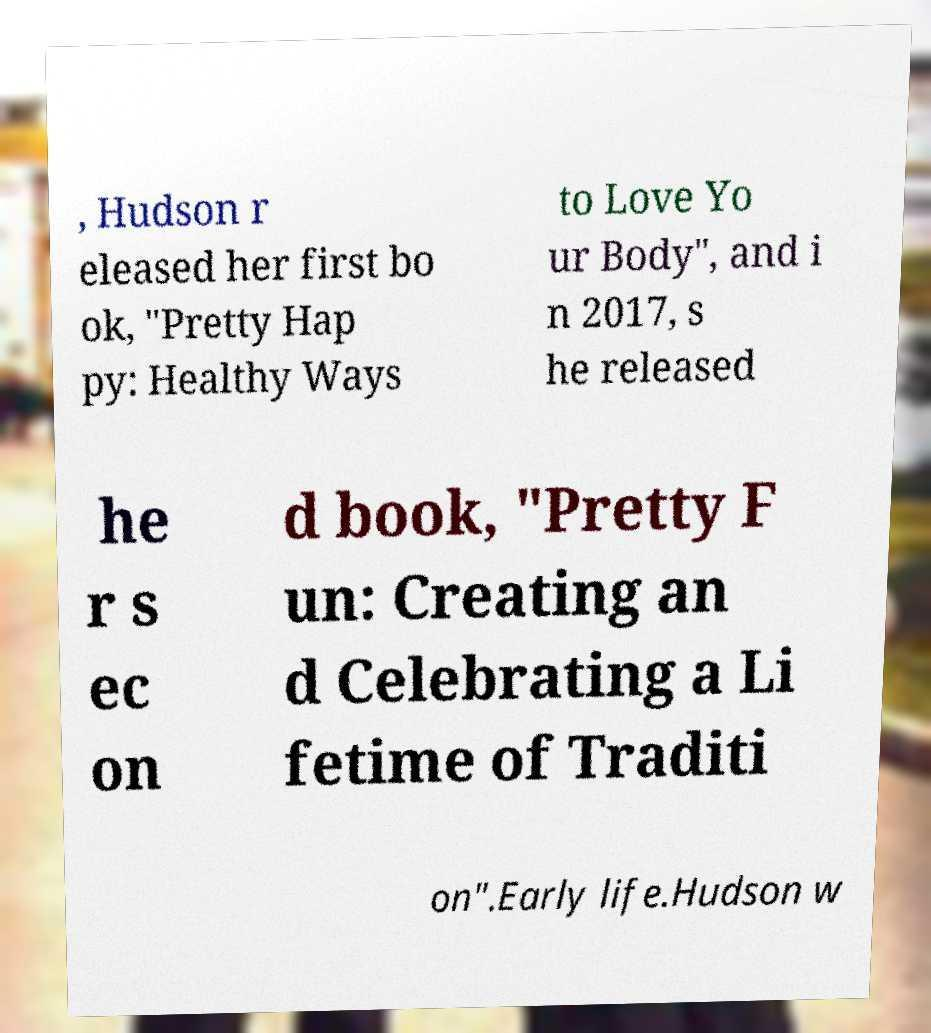Could you assist in decoding the text presented in this image and type it out clearly? , Hudson r eleased her first bo ok, "Pretty Hap py: Healthy Ways to Love Yo ur Body", and i n 2017, s he released he r s ec on d book, "Pretty F un: Creating an d Celebrating a Li fetime of Traditi on".Early life.Hudson w 